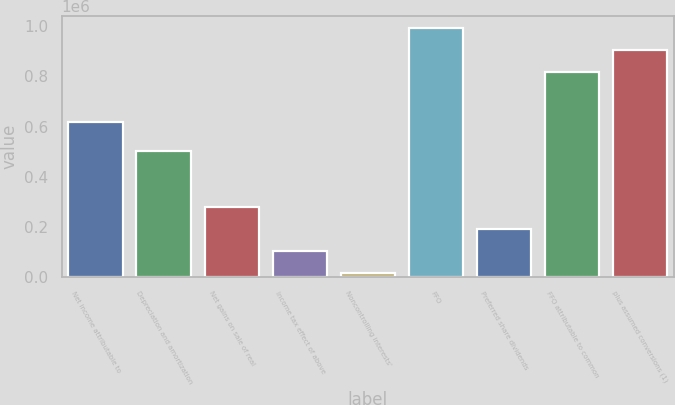Convert chart to OTSL. <chart><loc_0><loc_0><loc_500><loc_500><bar_chart><fcel>Net income attributable to<fcel>Depreciation and amortization<fcel>Net gains on sale of real<fcel>Income tax effect of above<fcel>Noncontrolling interests'<fcel>FFO<fcel>Preferred share dividends<fcel>FFO attributable to common<fcel>plus assumed conversions (1)<nl><fcel>617260<fcel>504407<fcel>277587<fcel>103628<fcel>16649<fcel>992410<fcel>190607<fcel>818452<fcel>905431<nl></chart> 